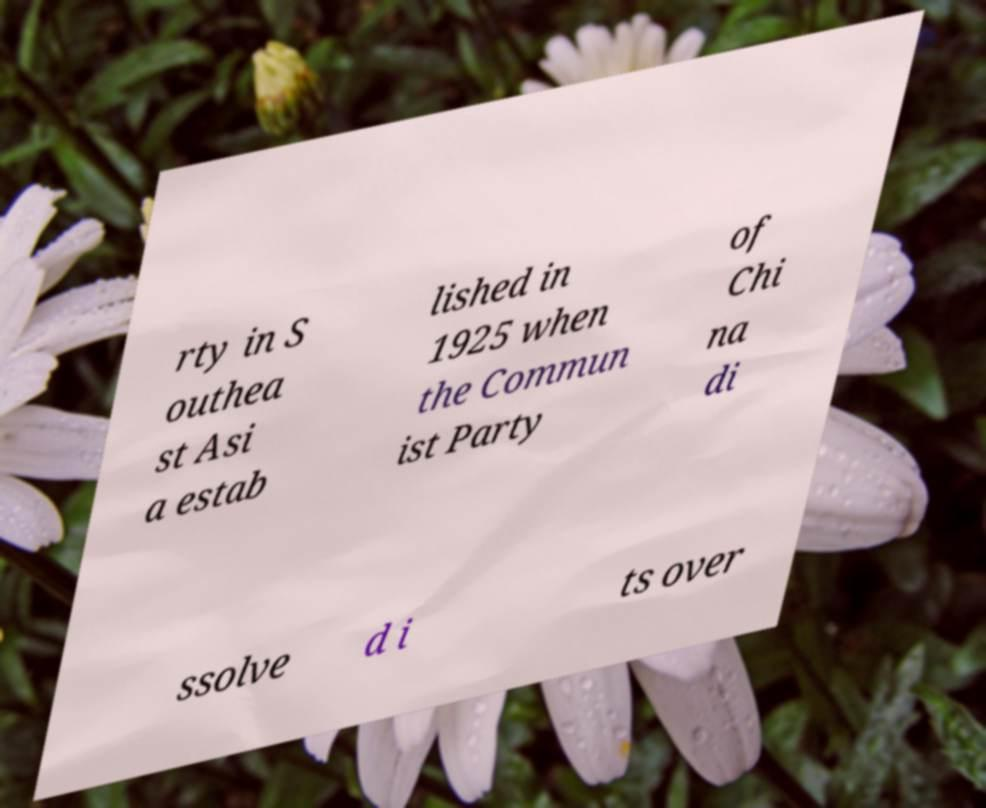I need the written content from this picture converted into text. Can you do that? rty in S outhea st Asi a estab lished in 1925 when the Commun ist Party of Chi na di ssolve d i ts over 